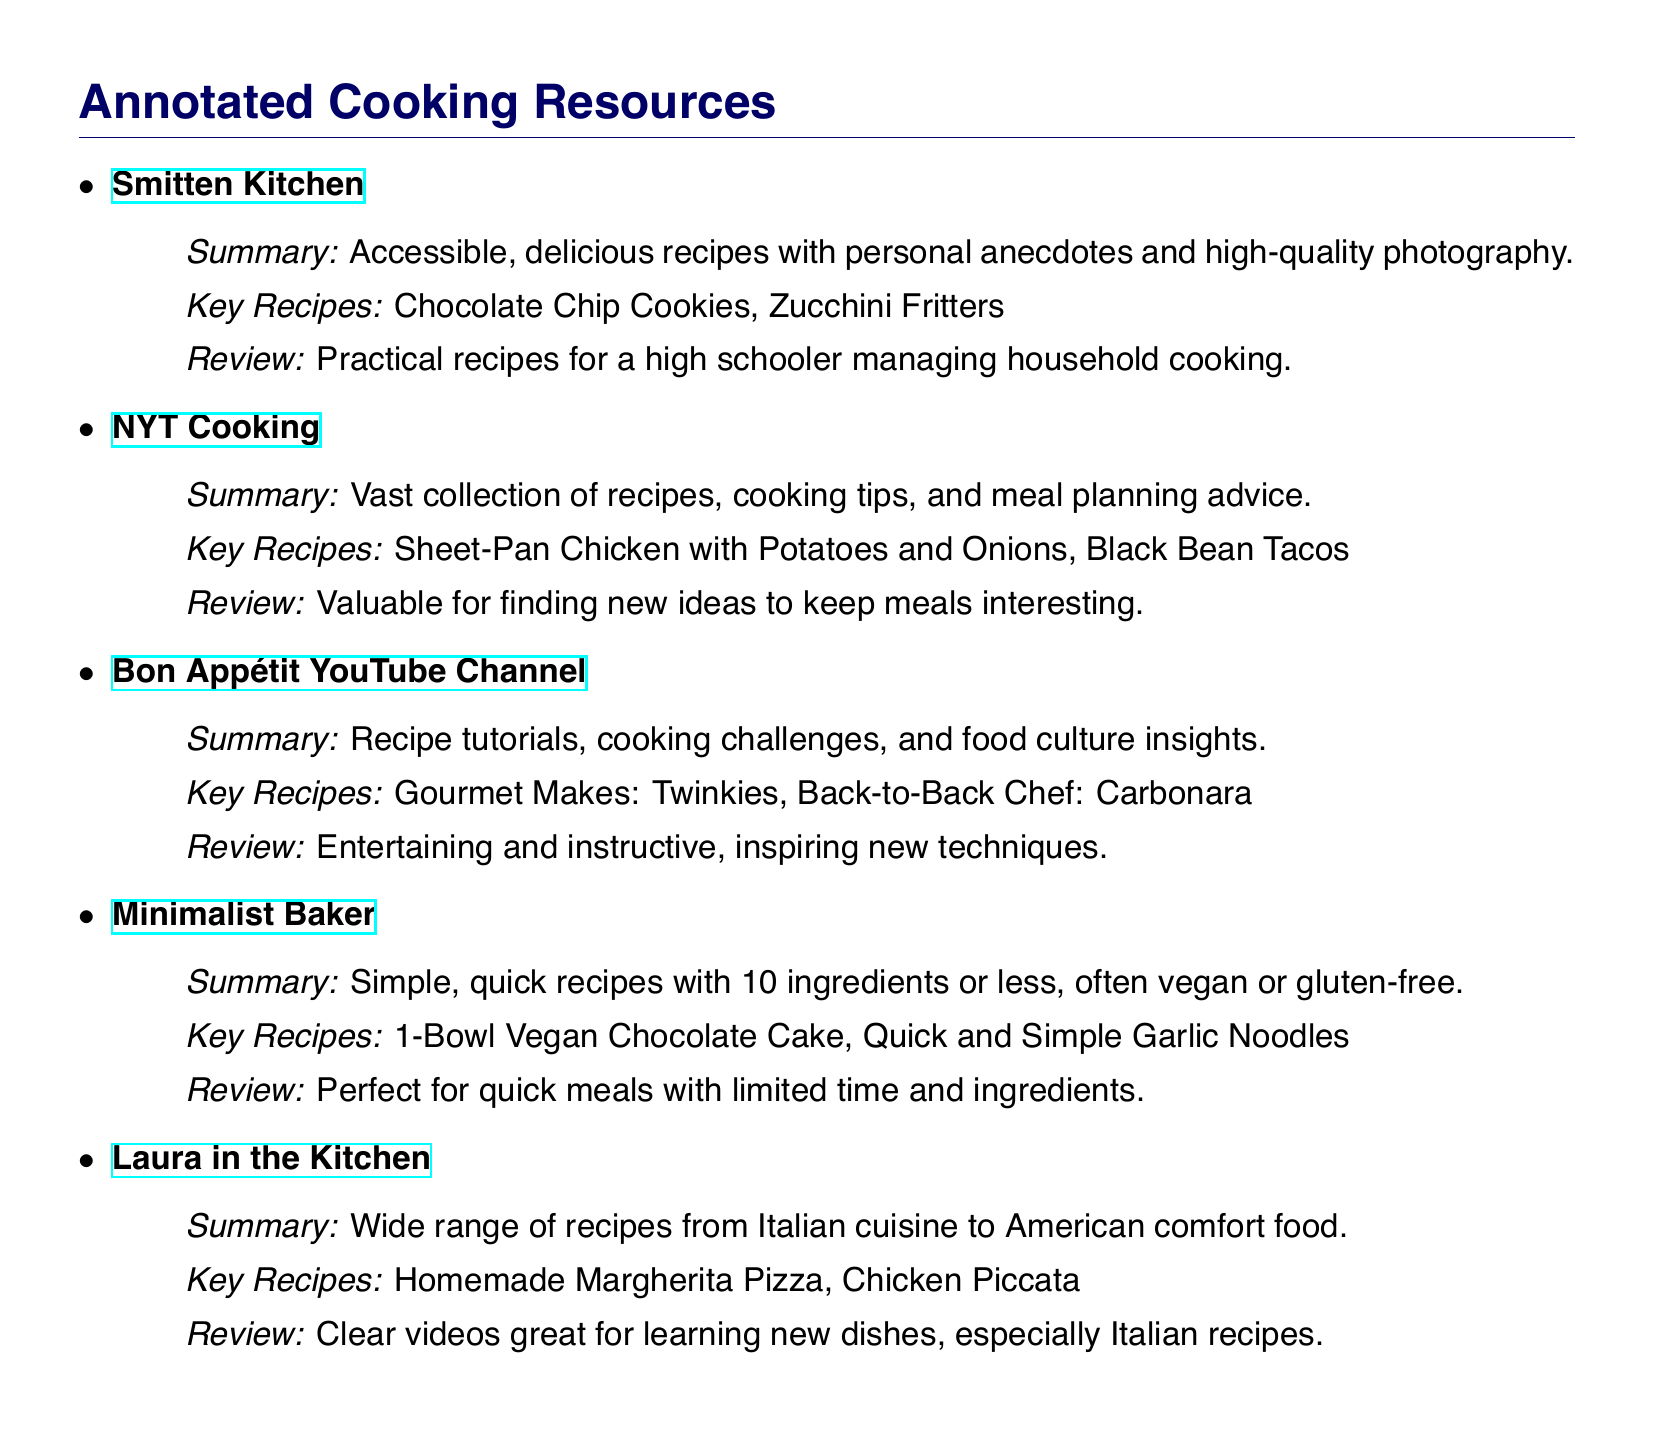What is the first cooking blog listed? The first cooking blog in the document is "Smitten Kitchen."
Answer: Smitten Kitchen How many key recipes are listed for NYT Cooking? The number of key recipes listed for NYT Cooking is two.
Answer: Two What is the main focus of Minimalist Baker recipes? The main focus of Minimalist Baker recipes is on simple, quick recipes with 10 ingredients or less.
Answer: Simple, quick recipes Which YouTube channel features cooking challenges? The YouTube channel that features cooking challenges is "Bon Appétit."
Answer: Bon Appétit What are the key recipes from Laura in the Kitchen? The key recipes from Laura in the Kitchen are "Homemade Margherita Pizza" and "Chicken Piccata."
Answer: Homemade Margherita Pizza, Chicken Piccata Which resource is mentioned for meal planning advice? The resource mentioned for meal planning advice is "NYT Cooking."
Answer: NYT Cooking What type of cuisine is prominently featured in Laura in the Kitchen? The type of cuisine prominently featured in Laura in the Kitchen is Italian cuisine.
Answer: Italian cuisine What is a characteristic of recipes from Minimalist Baker? A characteristic of recipes from Minimalist Baker is that they are often vegan or gluten-free.
Answer: Often vegan or gluten-free 